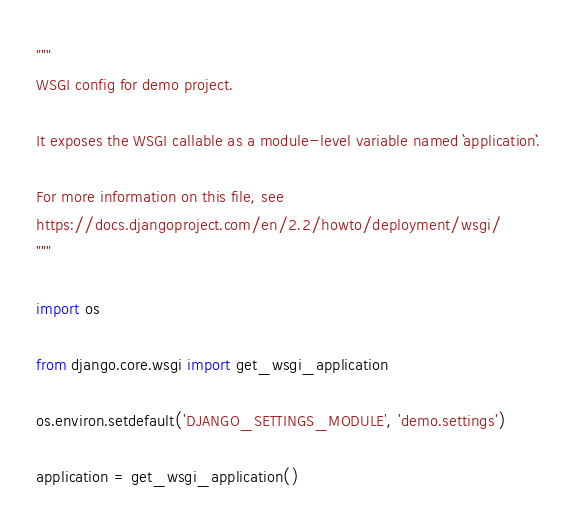Convert code to text. <code><loc_0><loc_0><loc_500><loc_500><_Python_>"""
WSGI config for demo project.

It exposes the WSGI callable as a module-level variable named ``application``.

For more information on this file, see
https://docs.djangoproject.com/en/2.2/howto/deployment/wsgi/
"""

import os

from django.core.wsgi import get_wsgi_application

os.environ.setdefault('DJANGO_SETTINGS_MODULE', 'demo.settings')

application = get_wsgi_application()
</code> 